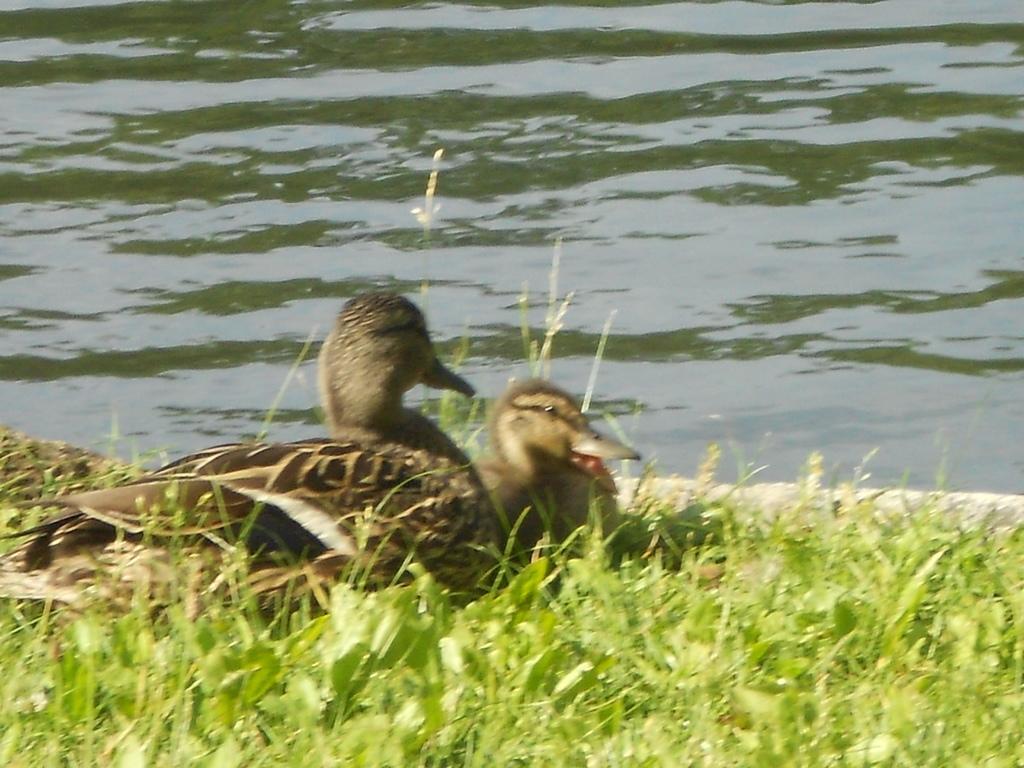Could you give a brief overview of what you see in this image? In this picture there are two ducks sitting on the grass. Behind there is a lake water. 